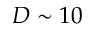Convert formula to latex. <formula><loc_0><loc_0><loc_500><loc_500>D \sim 1 0</formula> 